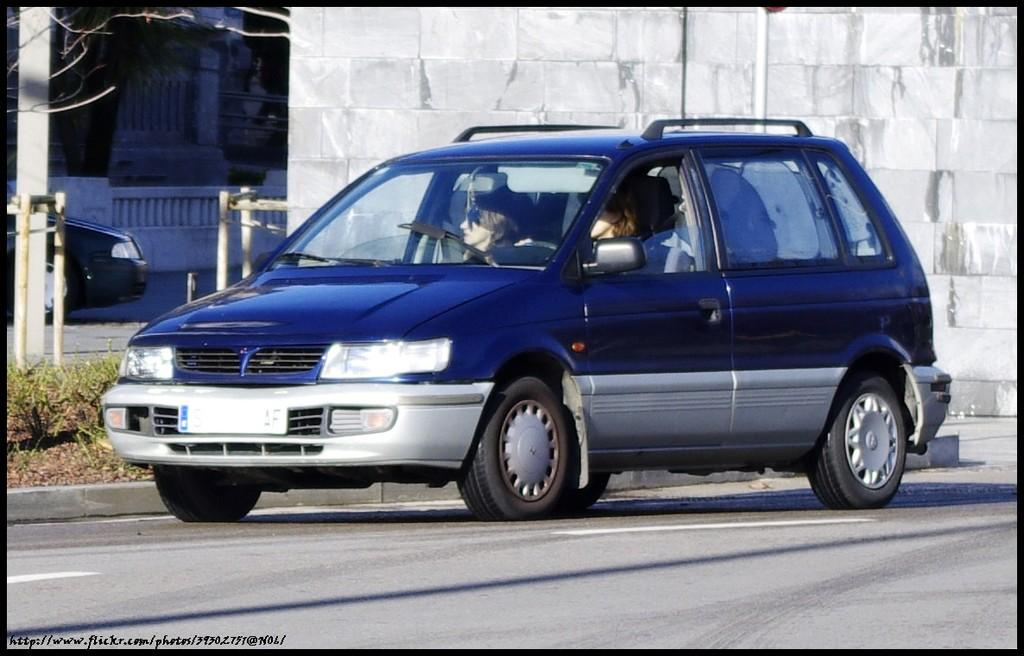How many people are in the car in the image? There are two persons in the car. Where is the car located in the image? The car is on the road. What can be seen in the background of the image? There is a vehicle, a wall, a railing, plants, branches of a tree, and poles in the background. Can you describe the objects in the background? There are objects in the background, but their specific nature is not clear from the image. What type of punishment is being handed out to the snakes in the image? There are no snakes present in the image, so no punishment is being handed out. 